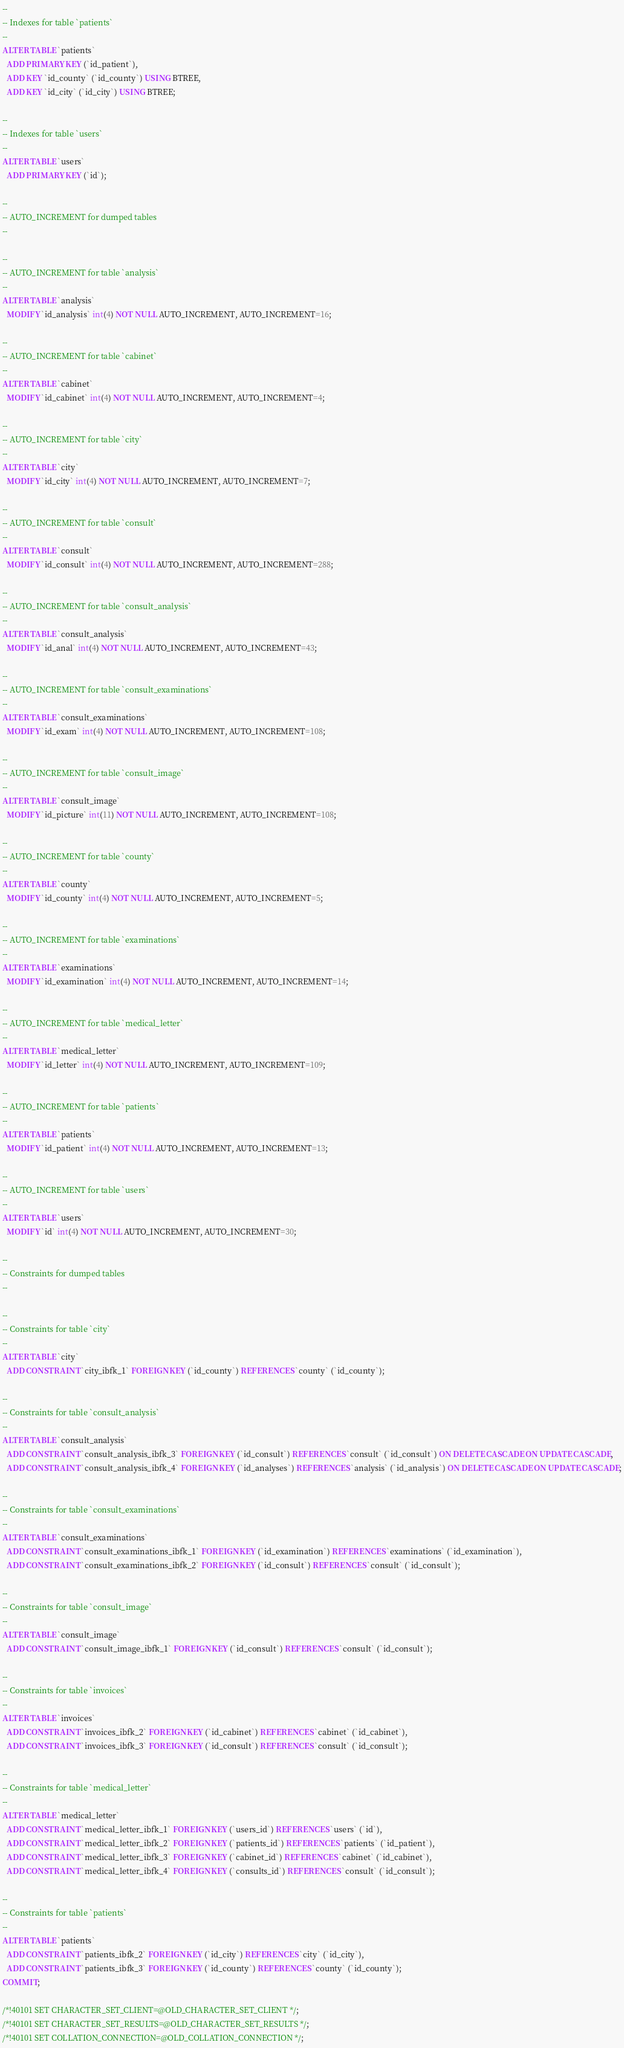<code> <loc_0><loc_0><loc_500><loc_500><_SQL_>
--
-- Indexes for table `patients`
--
ALTER TABLE `patients`
  ADD PRIMARY KEY (`id_patient`),
  ADD KEY `id_county` (`id_county`) USING BTREE,
  ADD KEY `id_city` (`id_city`) USING BTREE;

--
-- Indexes for table `users`
--
ALTER TABLE `users`
  ADD PRIMARY KEY (`id`);

--
-- AUTO_INCREMENT for dumped tables
--

--
-- AUTO_INCREMENT for table `analysis`
--
ALTER TABLE `analysis`
  MODIFY `id_analysis` int(4) NOT NULL AUTO_INCREMENT, AUTO_INCREMENT=16;

--
-- AUTO_INCREMENT for table `cabinet`
--
ALTER TABLE `cabinet`
  MODIFY `id_cabinet` int(4) NOT NULL AUTO_INCREMENT, AUTO_INCREMENT=4;

--
-- AUTO_INCREMENT for table `city`
--
ALTER TABLE `city`
  MODIFY `id_city` int(4) NOT NULL AUTO_INCREMENT, AUTO_INCREMENT=7;

--
-- AUTO_INCREMENT for table `consult`
--
ALTER TABLE `consult`
  MODIFY `id_consult` int(4) NOT NULL AUTO_INCREMENT, AUTO_INCREMENT=288;

--
-- AUTO_INCREMENT for table `consult_analysis`
--
ALTER TABLE `consult_analysis`
  MODIFY `id_anal` int(4) NOT NULL AUTO_INCREMENT, AUTO_INCREMENT=43;

--
-- AUTO_INCREMENT for table `consult_examinations`
--
ALTER TABLE `consult_examinations`
  MODIFY `id_exam` int(4) NOT NULL AUTO_INCREMENT, AUTO_INCREMENT=108;

--
-- AUTO_INCREMENT for table `consult_image`
--
ALTER TABLE `consult_image`
  MODIFY `id_picture` int(11) NOT NULL AUTO_INCREMENT, AUTO_INCREMENT=108;

--
-- AUTO_INCREMENT for table `county`
--
ALTER TABLE `county`
  MODIFY `id_county` int(4) NOT NULL AUTO_INCREMENT, AUTO_INCREMENT=5;

--
-- AUTO_INCREMENT for table `examinations`
--
ALTER TABLE `examinations`
  MODIFY `id_examination` int(4) NOT NULL AUTO_INCREMENT, AUTO_INCREMENT=14;

--
-- AUTO_INCREMENT for table `medical_letter`
--
ALTER TABLE `medical_letter`
  MODIFY `id_letter` int(4) NOT NULL AUTO_INCREMENT, AUTO_INCREMENT=109;

--
-- AUTO_INCREMENT for table `patients`
--
ALTER TABLE `patients`
  MODIFY `id_patient` int(4) NOT NULL AUTO_INCREMENT, AUTO_INCREMENT=13;

--
-- AUTO_INCREMENT for table `users`
--
ALTER TABLE `users`
  MODIFY `id` int(4) NOT NULL AUTO_INCREMENT, AUTO_INCREMENT=30;

--
-- Constraints for dumped tables
--

--
-- Constraints for table `city`
--
ALTER TABLE `city`
  ADD CONSTRAINT `city_ibfk_1` FOREIGN KEY (`id_county`) REFERENCES `county` (`id_county`);

--
-- Constraints for table `consult_analysis`
--
ALTER TABLE `consult_analysis`
  ADD CONSTRAINT `consult_analysis_ibfk_3` FOREIGN KEY (`id_consult`) REFERENCES `consult` (`id_consult`) ON DELETE CASCADE ON UPDATE CASCADE,
  ADD CONSTRAINT `consult_analysis_ibfk_4` FOREIGN KEY (`id_analyses`) REFERENCES `analysis` (`id_analysis`) ON DELETE CASCADE ON UPDATE CASCADE;

--
-- Constraints for table `consult_examinations`
--
ALTER TABLE `consult_examinations`
  ADD CONSTRAINT `consult_examinations_ibfk_1` FOREIGN KEY (`id_examination`) REFERENCES `examinations` (`id_examination`),
  ADD CONSTRAINT `consult_examinations_ibfk_2` FOREIGN KEY (`id_consult`) REFERENCES `consult` (`id_consult`);

--
-- Constraints for table `consult_image`
--
ALTER TABLE `consult_image`
  ADD CONSTRAINT `consult_image_ibfk_1` FOREIGN KEY (`id_consult`) REFERENCES `consult` (`id_consult`);

--
-- Constraints for table `invoices`
--
ALTER TABLE `invoices`
  ADD CONSTRAINT `invoices_ibfk_2` FOREIGN KEY (`id_cabinet`) REFERENCES `cabinet` (`id_cabinet`),
  ADD CONSTRAINT `invoices_ibfk_3` FOREIGN KEY (`id_consult`) REFERENCES `consult` (`id_consult`);

--
-- Constraints for table `medical_letter`
--
ALTER TABLE `medical_letter`
  ADD CONSTRAINT `medical_letter_ibfk_1` FOREIGN KEY (`users_id`) REFERENCES `users` (`id`),
  ADD CONSTRAINT `medical_letter_ibfk_2` FOREIGN KEY (`patients_id`) REFERENCES `patients` (`id_patient`),
  ADD CONSTRAINT `medical_letter_ibfk_3` FOREIGN KEY (`cabinet_id`) REFERENCES `cabinet` (`id_cabinet`),
  ADD CONSTRAINT `medical_letter_ibfk_4` FOREIGN KEY (`consults_id`) REFERENCES `consult` (`id_consult`);

--
-- Constraints for table `patients`
--
ALTER TABLE `patients`
  ADD CONSTRAINT `patients_ibfk_2` FOREIGN KEY (`id_city`) REFERENCES `city` (`id_city`),
  ADD CONSTRAINT `patients_ibfk_3` FOREIGN KEY (`id_county`) REFERENCES `county` (`id_county`);
COMMIT;

/*!40101 SET CHARACTER_SET_CLIENT=@OLD_CHARACTER_SET_CLIENT */;
/*!40101 SET CHARACTER_SET_RESULTS=@OLD_CHARACTER_SET_RESULTS */;
/*!40101 SET COLLATION_CONNECTION=@OLD_COLLATION_CONNECTION */;
</code> 